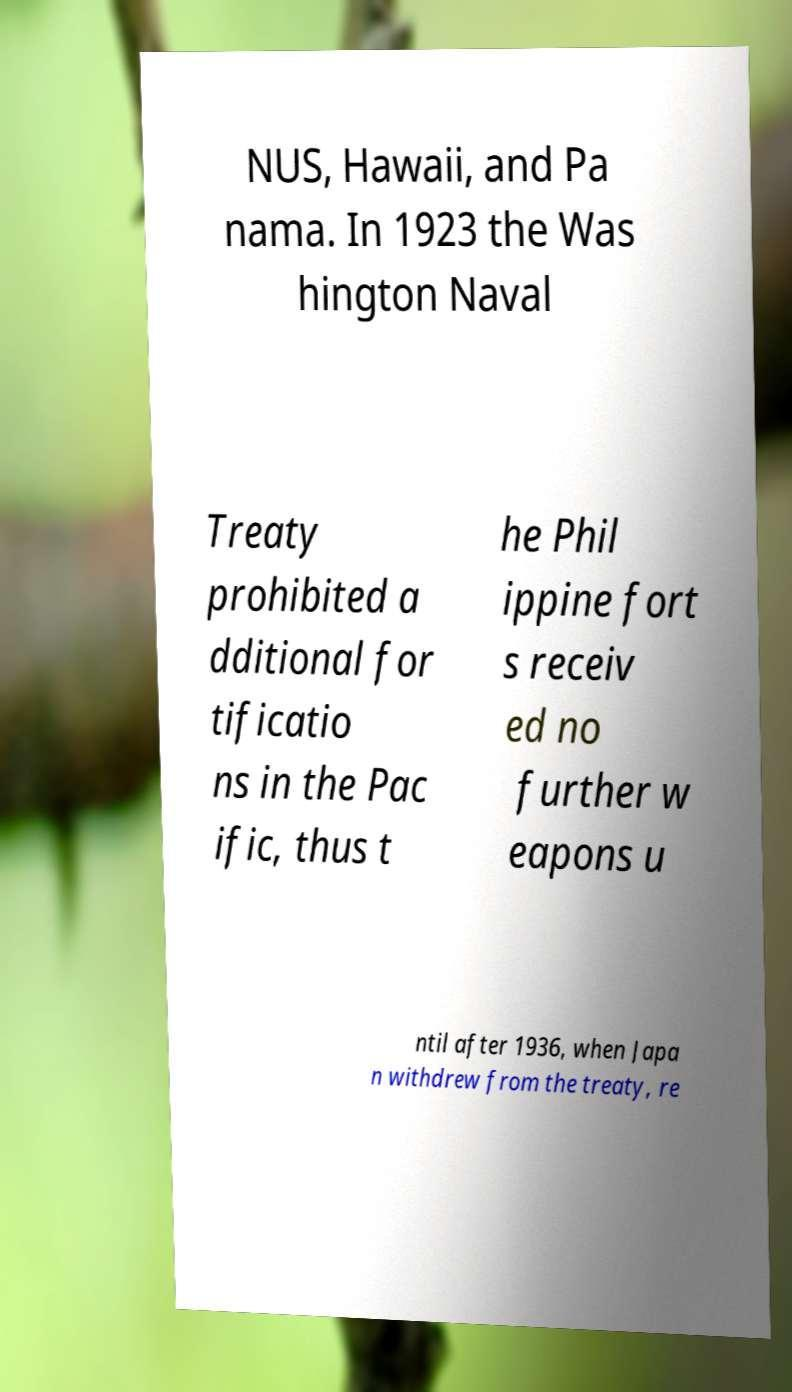Please identify and transcribe the text found in this image. NUS, Hawaii, and Pa nama. In 1923 the Was hington Naval Treaty prohibited a dditional for tificatio ns in the Pac ific, thus t he Phil ippine fort s receiv ed no further w eapons u ntil after 1936, when Japa n withdrew from the treaty, re 